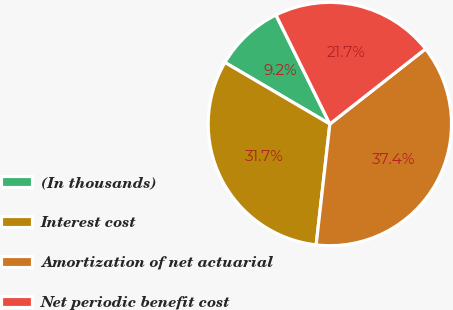<chart> <loc_0><loc_0><loc_500><loc_500><pie_chart><fcel>(In thousands)<fcel>Interest cost<fcel>Amortization of net actuarial<fcel>Net periodic benefit cost<nl><fcel>9.25%<fcel>31.65%<fcel>37.39%<fcel>21.71%<nl></chart> 